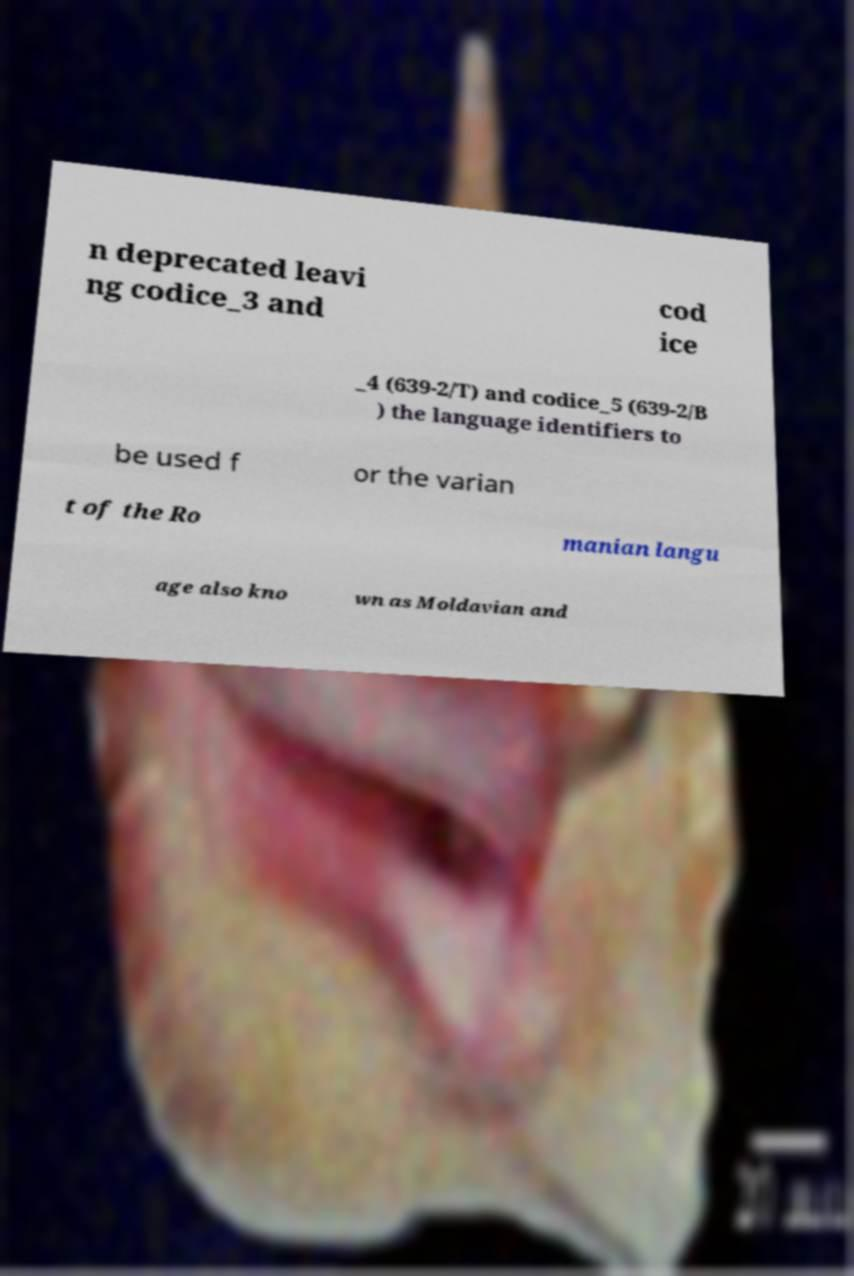Could you assist in decoding the text presented in this image and type it out clearly? n deprecated leavi ng codice_3 and cod ice _4 (639-2/T) and codice_5 (639-2/B ) the language identifiers to be used f or the varian t of the Ro manian langu age also kno wn as Moldavian and 